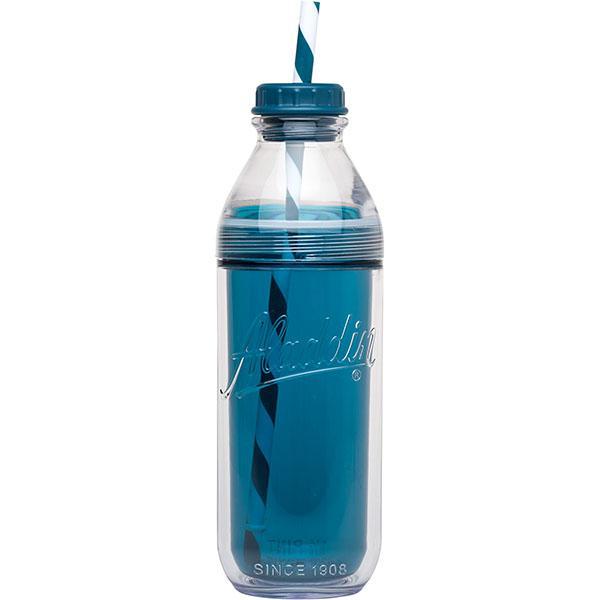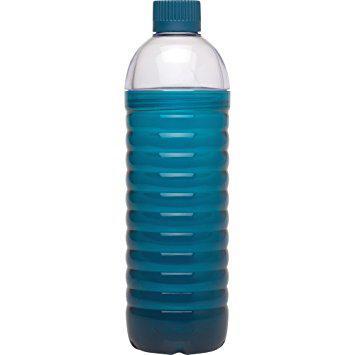The first image is the image on the left, the second image is the image on the right. For the images displayed, is the sentence "One bottle is filled with colored liquid and the other is filled with clear liquid." factually correct? Answer yes or no. No. The first image is the image on the left, the second image is the image on the right. Considering the images on both sides, is "An image shows a clear water bottle containing a solid-colored perforated cylindrical item inside at the bottom." valid? Answer yes or no. No. 